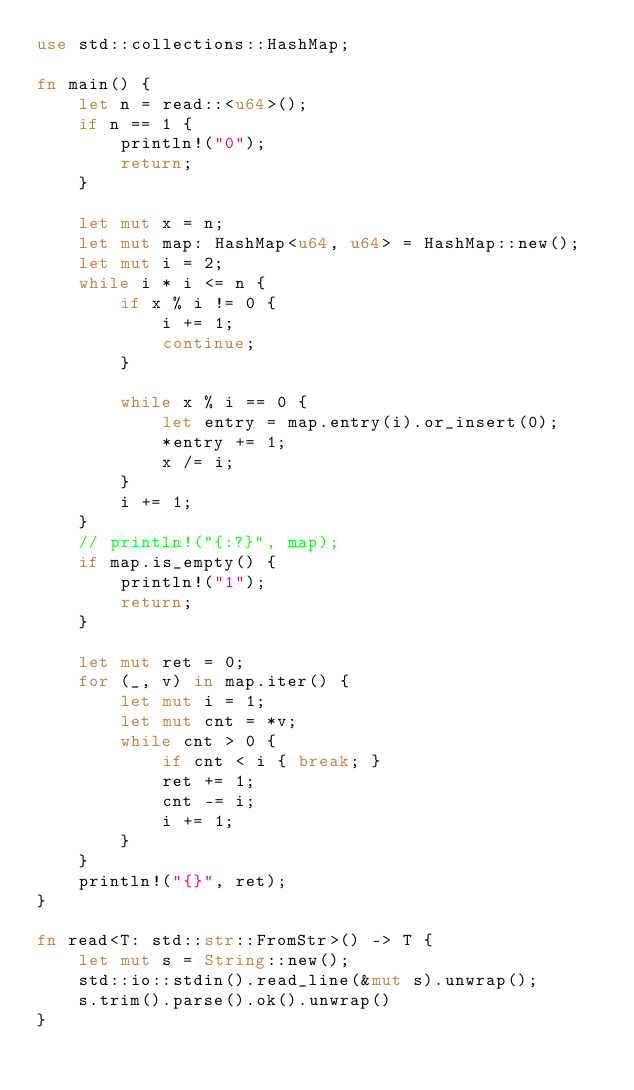Convert code to text. <code><loc_0><loc_0><loc_500><loc_500><_Rust_>use std::collections::HashMap;

fn main() {
    let n = read::<u64>();
    if n == 1 {
        println!("0");
        return;
    }

    let mut x = n;
    let mut map: HashMap<u64, u64> = HashMap::new();
    let mut i = 2;
    while i * i <= n {
        if x % i != 0 {
            i += 1;
            continue;
        }

        while x % i == 0 {
            let entry = map.entry(i).or_insert(0);
            *entry += 1;
            x /= i;
        }
        i += 1;
    }
    // println!("{:?}", map);
    if map.is_empty() {
        println!("1");
        return;
    }

    let mut ret = 0;
    for (_, v) in map.iter() {
        let mut i = 1;
        let mut cnt = *v;
        while cnt > 0 {
            if cnt < i { break; }
            ret += 1;
            cnt -= i;
            i += 1;
        }
    }
    println!("{}", ret);
}

fn read<T: std::str::FromStr>() -> T {
    let mut s = String::new();
    std::io::stdin().read_line(&mut s).unwrap();
    s.trim().parse().ok().unwrap()
}
</code> 